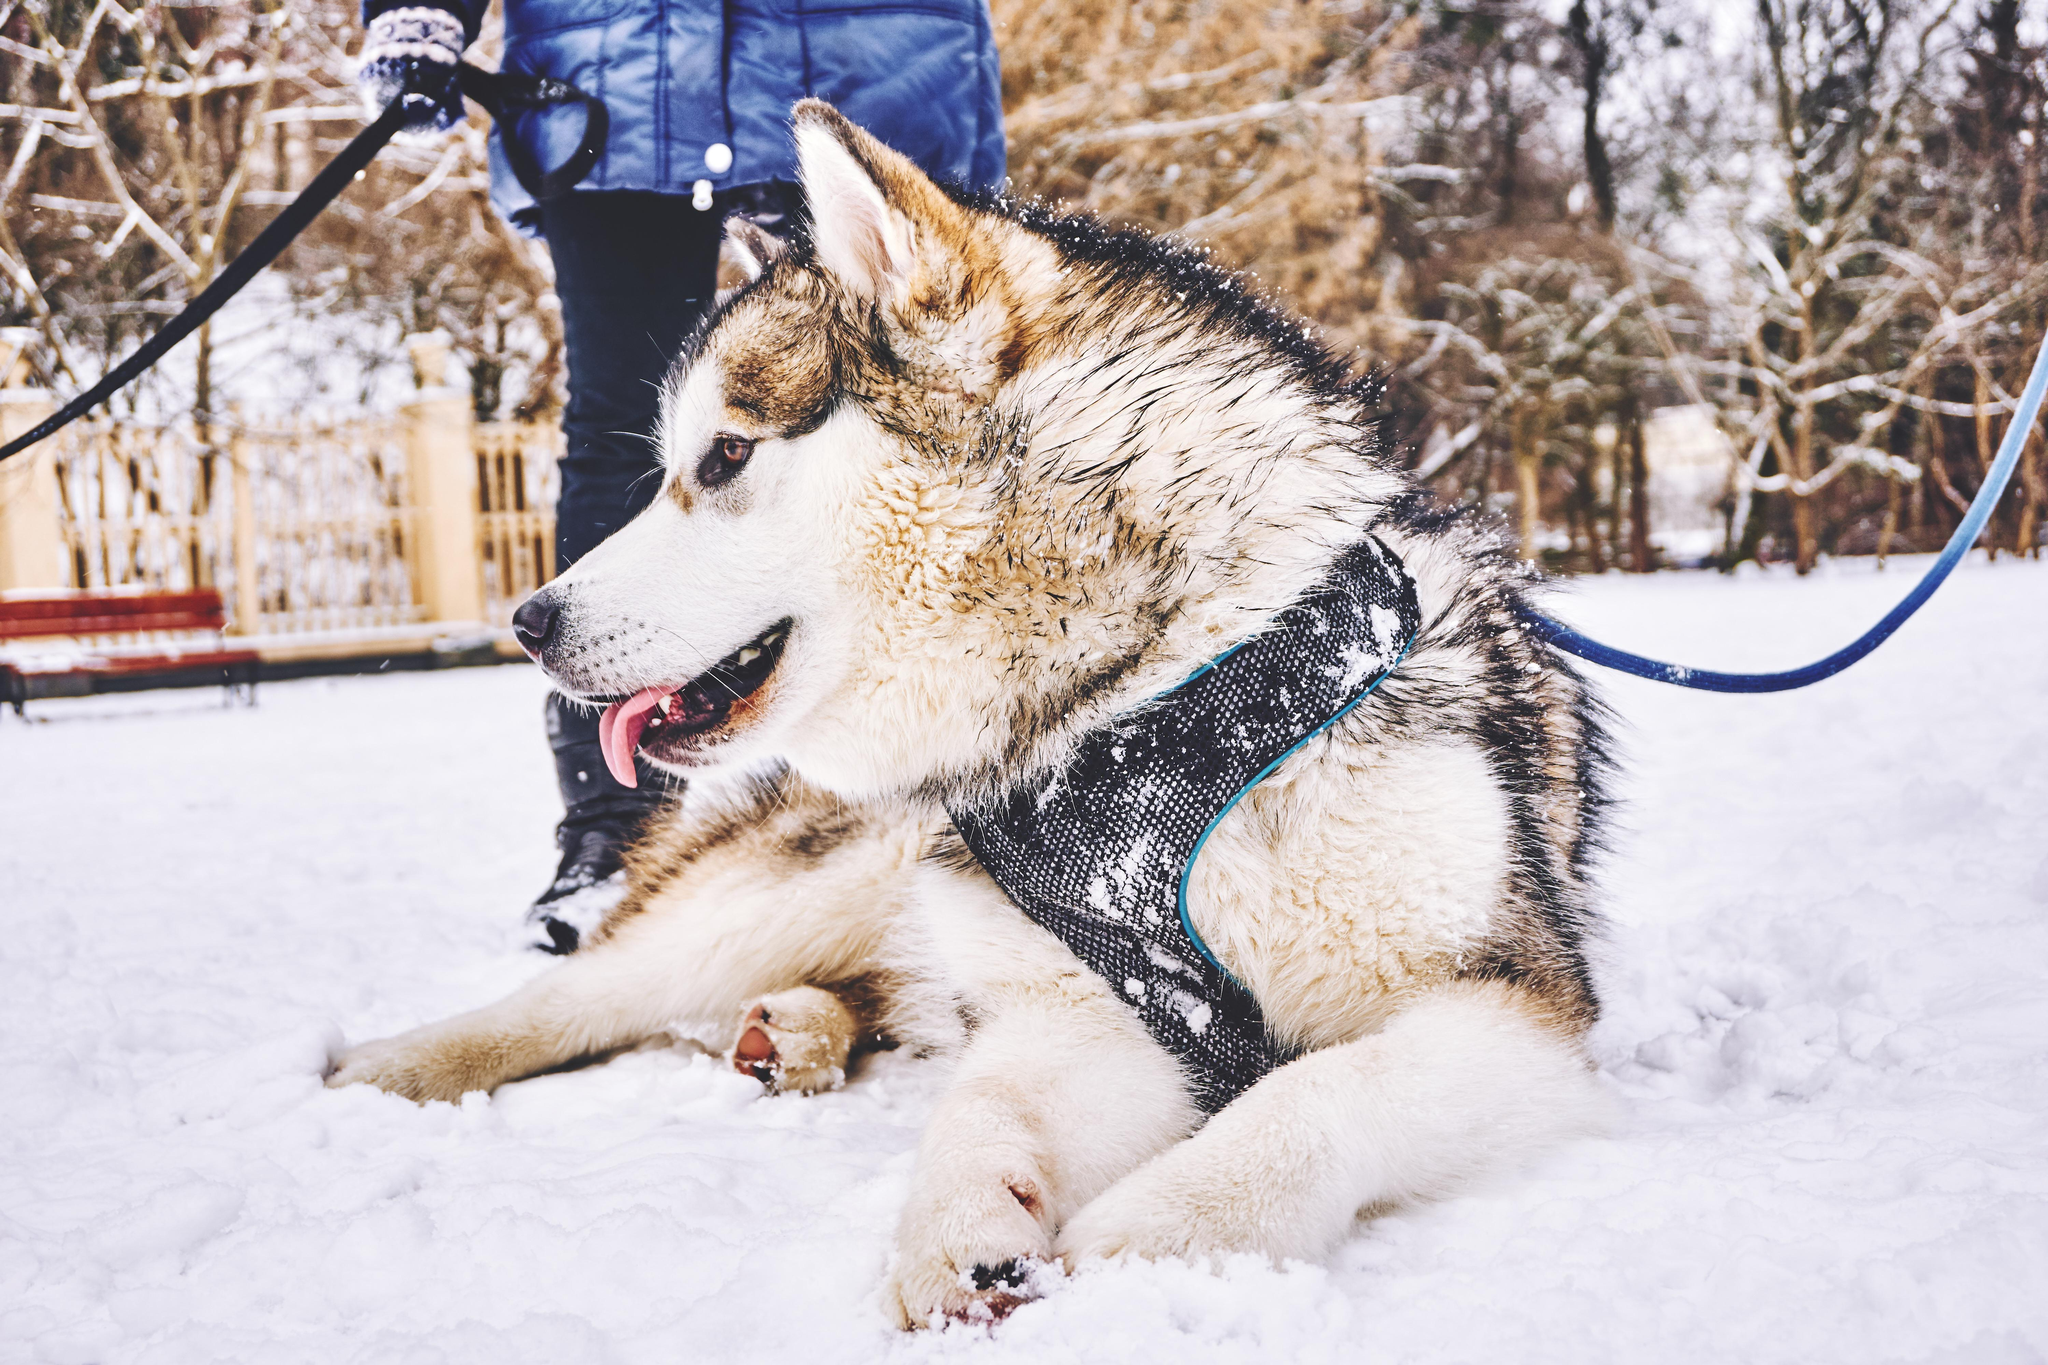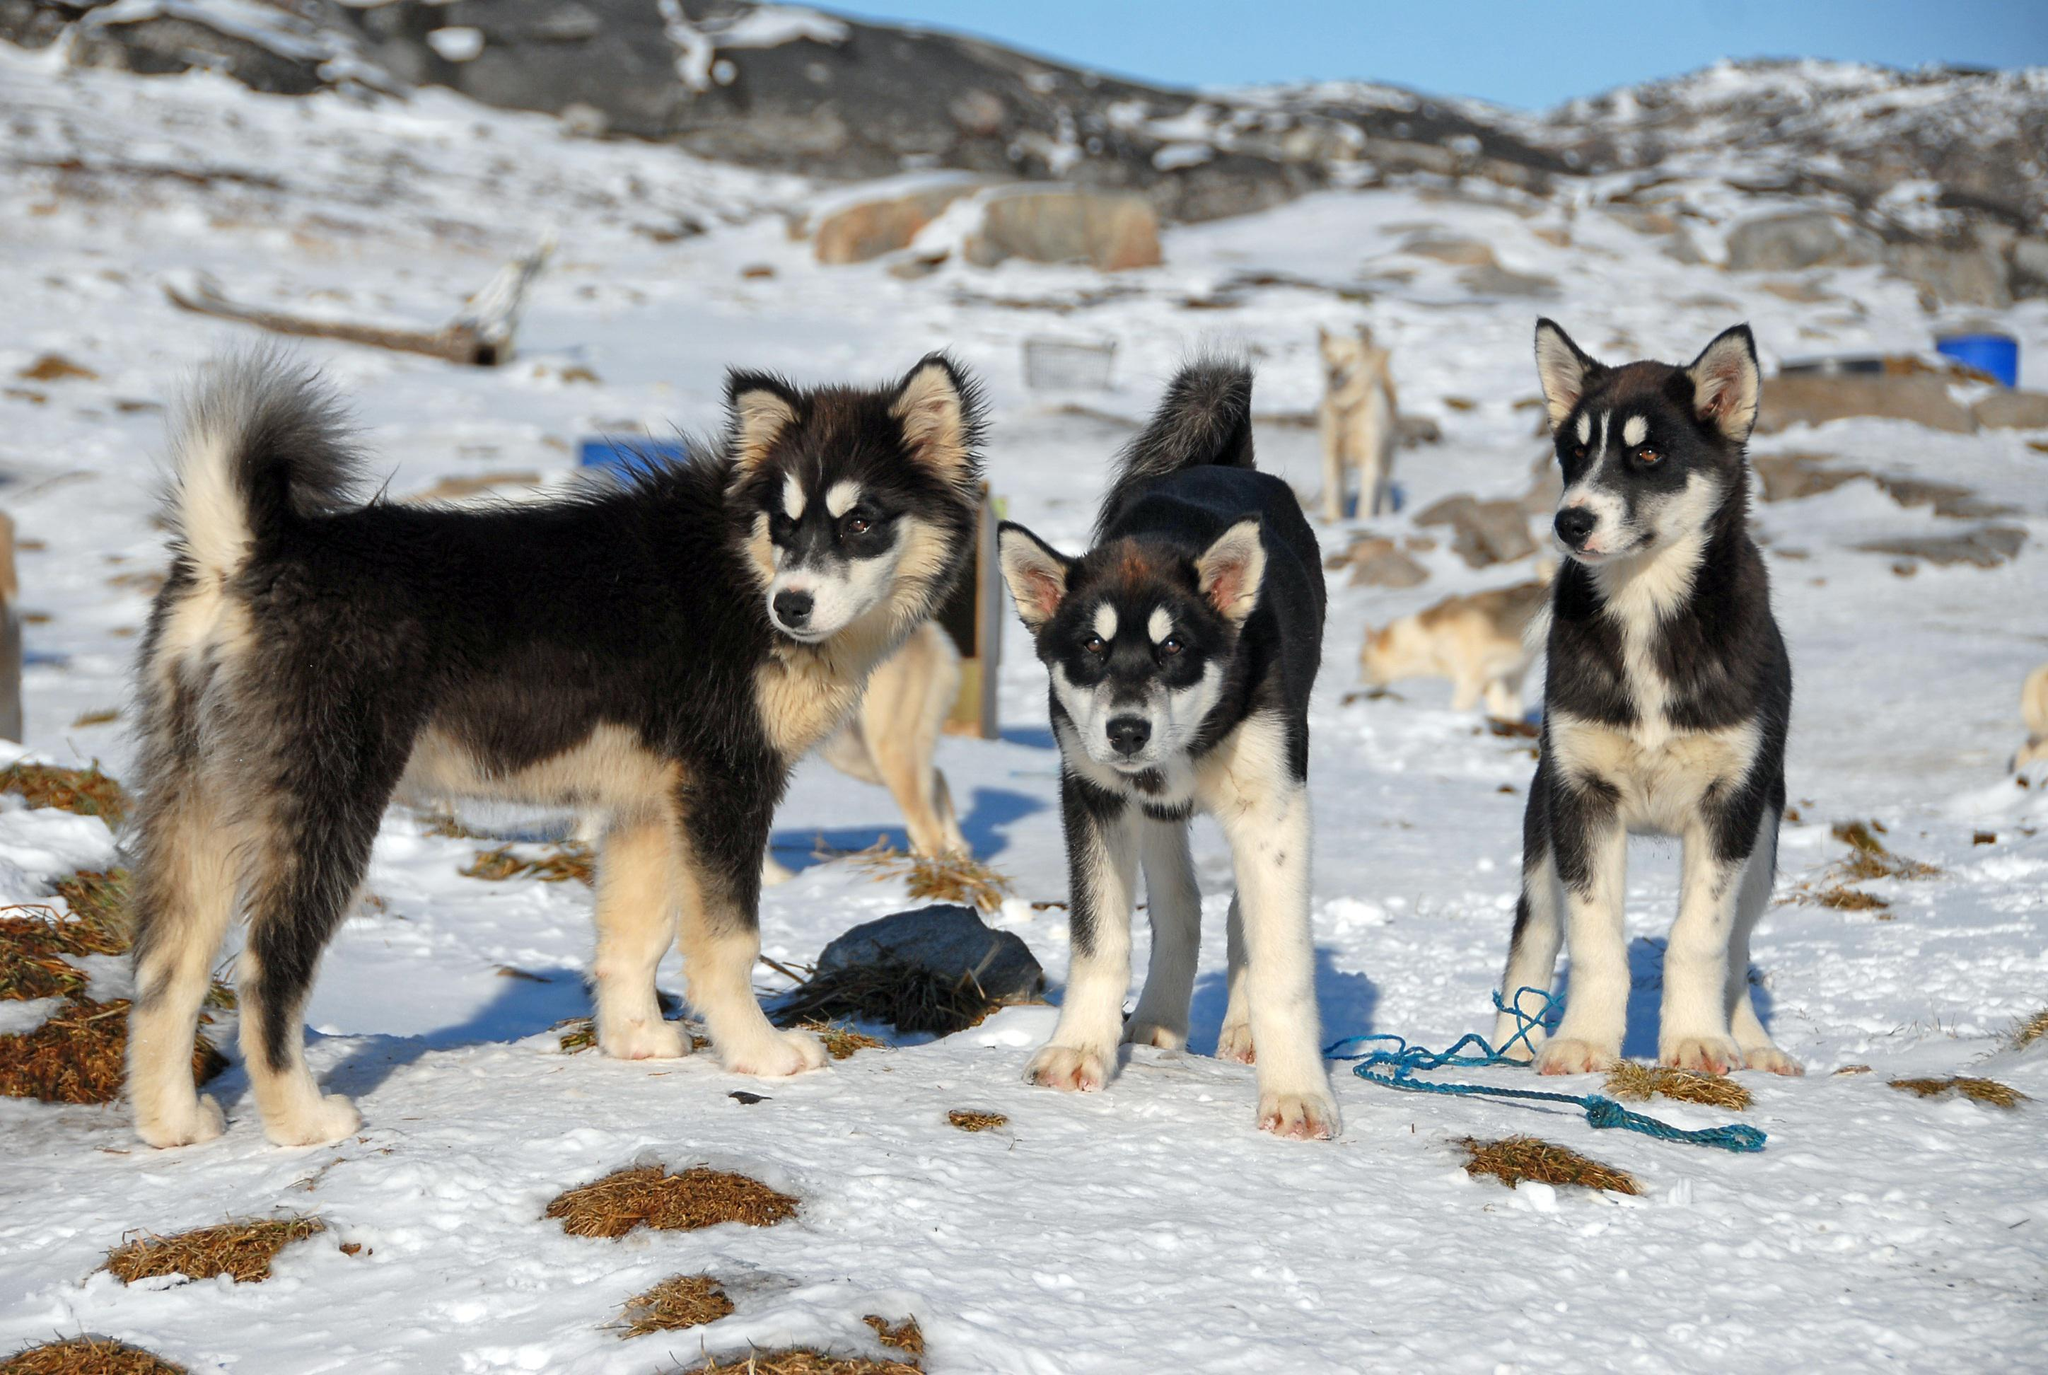The first image is the image on the left, the second image is the image on the right. Evaluate the accuracy of this statement regarding the images: "An image shows a sled driver on the right behind a team of dogs facing the camera.". Is it true? Answer yes or no. No. The first image is the image on the left, the second image is the image on the right. Considering the images on both sides, is "Only one rider is visible with the dogs." valid? Answer yes or no. Yes. 